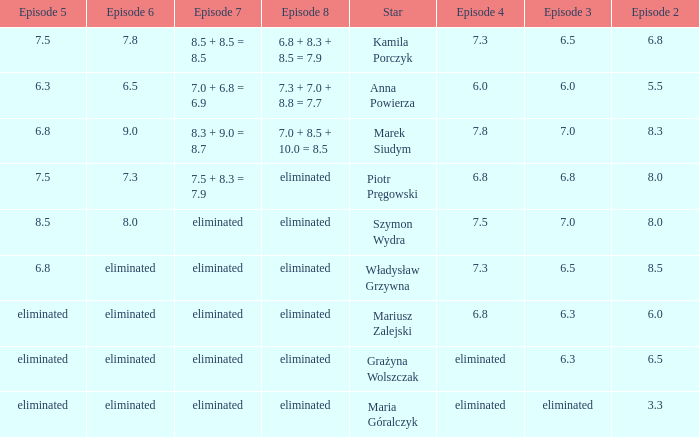Which episode 4 has a Star of anna powierza? 6.0. 